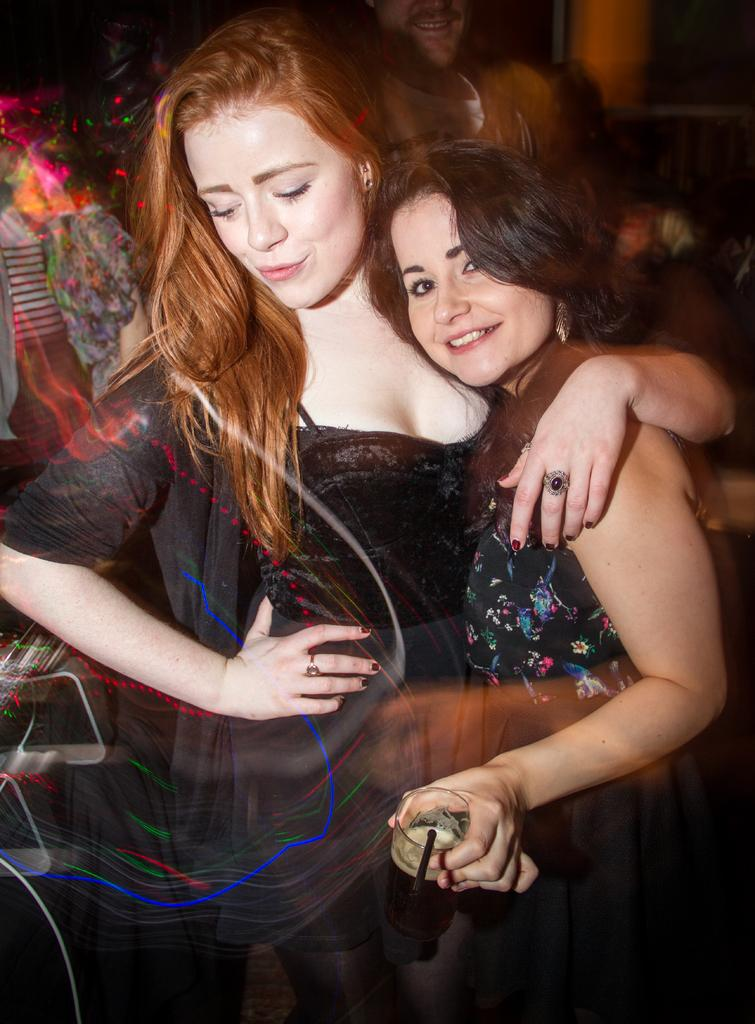How many people are in the image? There are people in the image, but the exact number is not specified. What is the woman holding in the image? The woman is holding a glass with a drink in the image. What is used to sip the drink in the glass? There is a straw in the glass. What is the condition of the rake in the image? There is no rake present in the image. Who is the manager of the people in the image? The facts do not mention a manager or any indication of a hierarchical structure among the people in the image. 